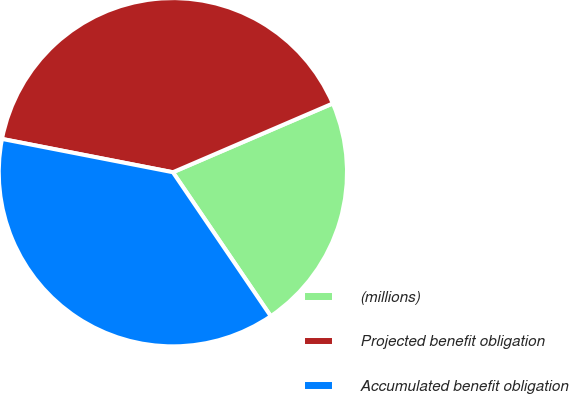<chart> <loc_0><loc_0><loc_500><loc_500><pie_chart><fcel>(millions)<fcel>Projected benefit obligation<fcel>Accumulated benefit obligation<nl><fcel>21.96%<fcel>40.47%<fcel>37.57%<nl></chart> 